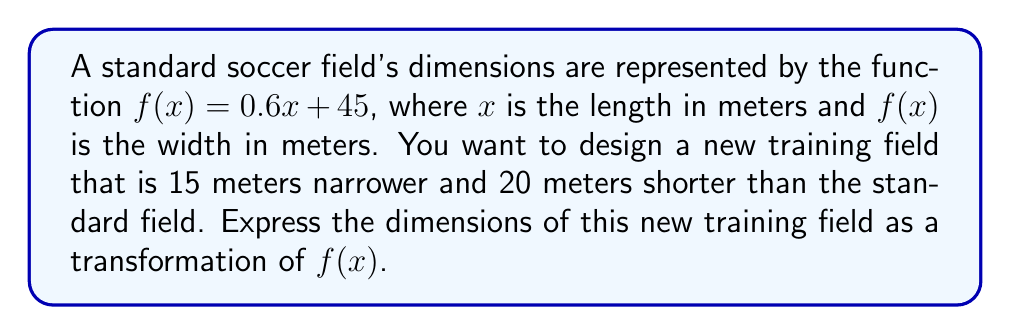Solve this math problem. To solve this problem, we need to apply two transformations to the original function $f(x) = 0.6x + 45$:

1. Horizontal shift: The new field is 20 meters shorter, so we need to shift the function 20 units to the left. This is done by replacing $x$ with $(x + 20)$.

2. Vertical shift: The new field is 15 meters narrower, so we need to shift the function 15 units down. This is done by subtracting 15 from the entire function.

Step 1: Apply the horizontal shift
$f(x + 20) = 0.6(x + 20) + 45$

Step 2: Apply the vertical shift
$g(x) = f(x + 20) - 15$

Step 3: Simplify the resulting function
$g(x) = 0.6(x + 20) + 45 - 15$
$g(x) = 0.6x + 12 + 45 - 15$
$g(x) = 0.6x + 42$

Therefore, the dimensions of the new training field can be expressed as the function $g(x) = 0.6x + 42$, where $x$ is the length in meters and $g(x)$ is the width in meters.
Answer: $g(x) = 0.6x + 42$ 